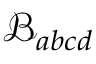<formula> <loc_0><loc_0><loc_500><loc_500>\mathcal { B } _ { a b c d }</formula> 